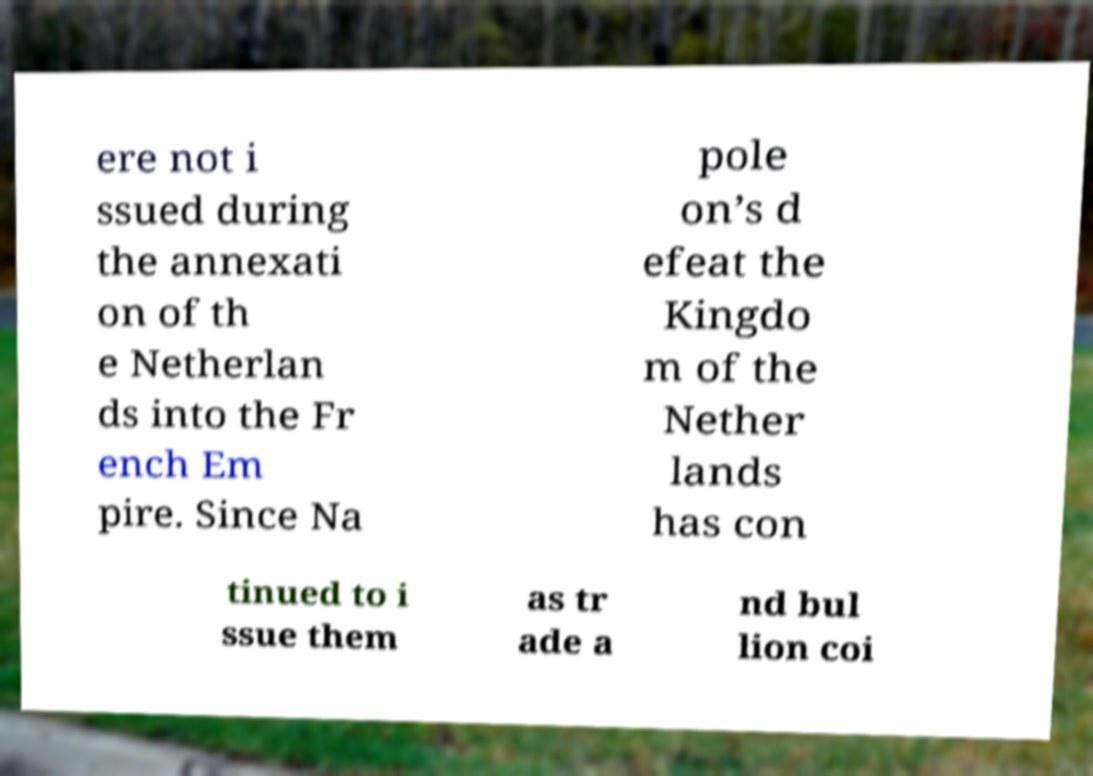There's text embedded in this image that I need extracted. Can you transcribe it verbatim? ere not i ssued during the annexati on of th e Netherlan ds into the Fr ench Em pire. Since Na pole on’s d efeat the Kingdo m of the Nether lands has con tinued to i ssue them as tr ade a nd bul lion coi 